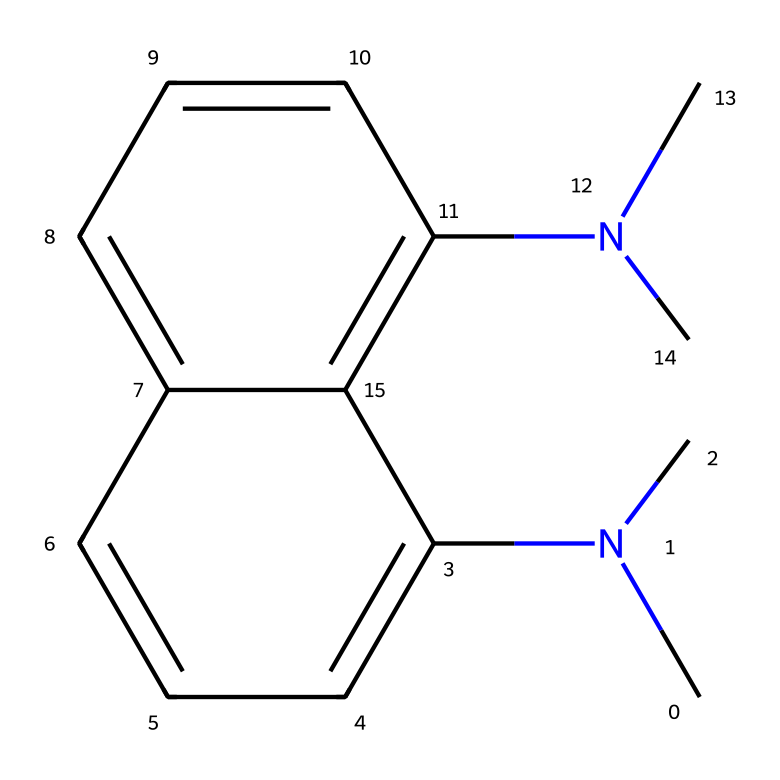How many nitrogen atoms are present in the molecule? The SMILES representation indicates two occurrences of 'N' in the structure, representing nitrogen atoms. Therefore, by counting the occurrences, we find there are 2 nitrogen atoms.
Answer: 2 What type of bonding is primarily present in the naphthalene rings? The naphthalene structure consists of fused benzene rings, which are joined by alternating single and double bonds, characteristic of aromatic compounds. This bonding provides stability and resonance in the structure.
Answer: aromatic bonding What is the functional group present in this molecule? The presence of nitrogen atoms with alkyl groups ('dimethylamino') indicates the presence of an amine functional group in the molecule. This is further supported by the two 'N(C)' notations, which represent dimethylamino groups.
Answer: amine What is the molecular weight of 1,8-bis(dimethylamino)naphthalene? By calculating the molecular weight from the atomic composition (2 nitrogen, 12 carbon, and 17 hydrogen atoms) using periodic table values, we find the total molecular weight to be approximately 225.32 g/mol.
Answer: 225.32 g/mol What property makes this compound a superior base? The presence of two basic amine groups (dimethylamino) provides a high electron density, resulting in strong proton-accepting ability, which is a key characteristic that qualifies it as a superbasic compound.
Answer: strong proton-accepting ability How does the presence of dimethyl amino groups influence the reactivity of this molecule? The dimethyl amino groups increase electron density around the nitrogen atoms, thus enhancing nucleophilicity and allowing for strong interactions with protons or electrophiles, which increases the overall reactivity of the molecule.
Answer: enhances nucleophilicity How does the structure of this compound enable its application in weather-resistant coatings? The stability of the aromatic naphthalene backbone, combined with strong basicity from the dimethylamino groups, provides chemical resistance and protective qualities, making it suitable for advanced coatings that endure harsh conditions.
Answer: chemical resistance 